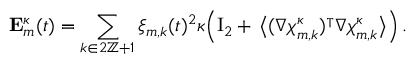<formula> <loc_0><loc_0><loc_500><loc_500>E _ { m } ^ { \kappa } ( t ) = \sum _ { k \in 2 { \mathbb { Z } } + 1 } \xi _ { m , k } ( t ) ^ { 2 } \kappa \left ( { I _ { 2 } } + \, \left \langle ( \nabla { \chi } _ { m , k } ^ { \kappa } ) ^ { \intercal } \nabla { \chi } _ { m , k } ^ { \kappa } \right \rangle \right ) \, .</formula> 